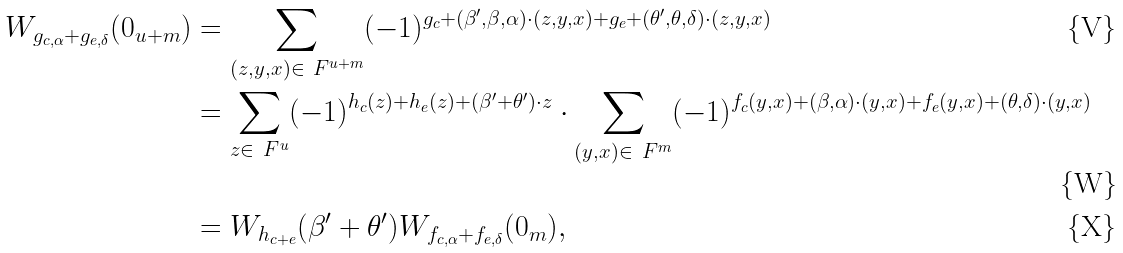Convert formula to latex. <formula><loc_0><loc_0><loc_500><loc_500>W _ { g _ { c , \alpha } + g _ { e , \delta } } ( 0 _ { u + m } ) & = \sum _ { ( z , y , x ) \in \ F ^ { u + m } } ( - 1 ) ^ { g _ { c } + ( \beta ^ { \prime } , \beta , \alpha ) \cdot ( z , y , x ) + g _ { e } + ( \theta ^ { \prime } , \theta , \delta ) \cdot ( z , y , x ) } \\ & = \sum _ { z \in \ F ^ { u } } ( - 1 ) ^ { h _ { c } ( z ) + h _ { e } ( z ) + ( \beta ^ { \prime } + \theta ^ { \prime } ) \cdot z } \cdot \sum _ { ( y , x ) \in \ F ^ { m } } ( - 1 ) ^ { f _ { c } ( y , x ) + ( \beta , \alpha ) \cdot ( y , x ) + f _ { e } ( y , x ) + ( \theta , \delta ) \cdot ( y , x ) } \\ & = W _ { h _ { c + e } } ( \beta ^ { \prime } + \theta ^ { \prime } ) W _ { f _ { c , \alpha } + f _ { e , \delta } } ( 0 _ { m } ) ,</formula> 